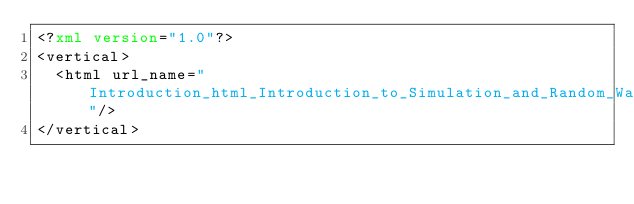Convert code to text. <code><loc_0><loc_0><loc_500><loc_500><_XML_><?xml version="1.0"?>
<vertical>
  <html url_name="Introduction_html_Introduction_to_Simulation_and_Random_Walks_vertical"/>
</vertical>
</code> 